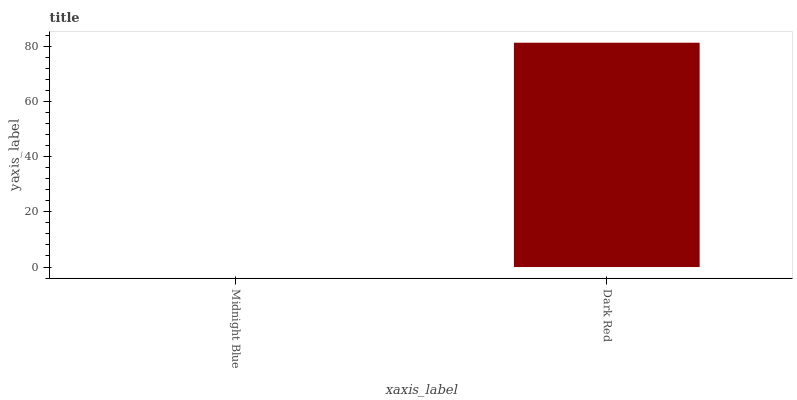Is Midnight Blue the minimum?
Answer yes or no. Yes. Is Dark Red the maximum?
Answer yes or no. Yes. Is Dark Red the minimum?
Answer yes or no. No. Is Dark Red greater than Midnight Blue?
Answer yes or no. Yes. Is Midnight Blue less than Dark Red?
Answer yes or no. Yes. Is Midnight Blue greater than Dark Red?
Answer yes or no. No. Is Dark Red less than Midnight Blue?
Answer yes or no. No. Is Dark Red the high median?
Answer yes or no. Yes. Is Midnight Blue the low median?
Answer yes or no. Yes. Is Midnight Blue the high median?
Answer yes or no. No. Is Dark Red the low median?
Answer yes or no. No. 